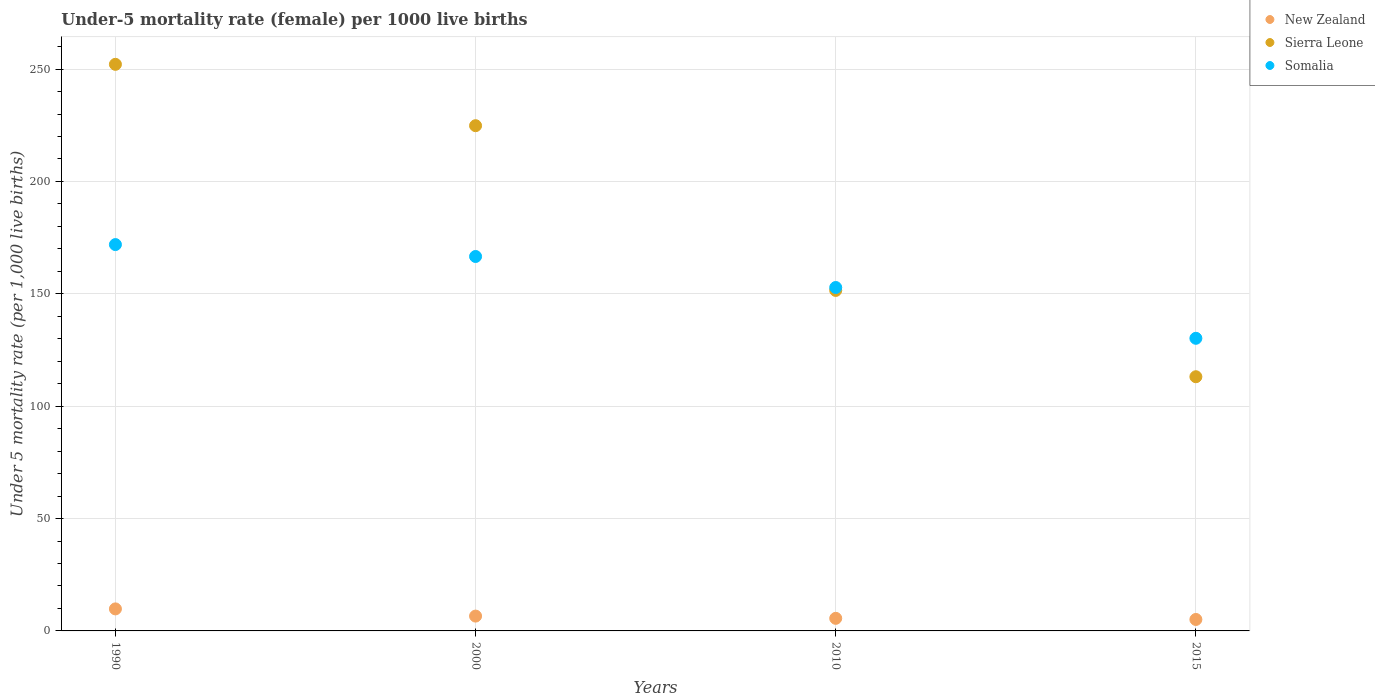How many different coloured dotlines are there?
Offer a very short reply. 3. What is the under-five mortality rate in Somalia in 2010?
Keep it short and to the point. 152.8. Across all years, what is the minimum under-five mortality rate in New Zealand?
Give a very brief answer. 5.1. In which year was the under-five mortality rate in Sierra Leone minimum?
Keep it short and to the point. 2015. What is the total under-five mortality rate in New Zealand in the graph?
Give a very brief answer. 27.1. What is the difference between the under-five mortality rate in New Zealand in 1990 and that in 2015?
Your response must be concise. 4.7. What is the difference between the under-five mortality rate in Somalia in 2015 and the under-five mortality rate in New Zealand in 2010?
Offer a very short reply. 124.6. What is the average under-five mortality rate in Sierra Leone per year?
Ensure brevity in your answer.  185.38. In the year 2015, what is the difference between the under-five mortality rate in Somalia and under-five mortality rate in Sierra Leone?
Offer a very short reply. 17.1. In how many years, is the under-five mortality rate in New Zealand greater than 250?
Your answer should be very brief. 0. What is the ratio of the under-five mortality rate in New Zealand in 1990 to that in 2000?
Keep it short and to the point. 1.48. Is the difference between the under-five mortality rate in Somalia in 1990 and 2000 greater than the difference between the under-five mortality rate in Sierra Leone in 1990 and 2000?
Your answer should be compact. No. What is the difference between the highest and the second highest under-five mortality rate in New Zealand?
Give a very brief answer. 3.2. What is the difference between the highest and the lowest under-five mortality rate in Sierra Leone?
Give a very brief answer. 139. In how many years, is the under-five mortality rate in Somalia greater than the average under-five mortality rate in Somalia taken over all years?
Make the answer very short. 2. Is it the case that in every year, the sum of the under-five mortality rate in Somalia and under-five mortality rate in Sierra Leone  is greater than the under-five mortality rate in New Zealand?
Make the answer very short. Yes. Is the under-five mortality rate in Somalia strictly greater than the under-five mortality rate in New Zealand over the years?
Offer a terse response. Yes. How many dotlines are there?
Your response must be concise. 3. Are the values on the major ticks of Y-axis written in scientific E-notation?
Your answer should be very brief. No. Does the graph contain any zero values?
Your response must be concise. No. How many legend labels are there?
Your answer should be compact. 3. What is the title of the graph?
Offer a terse response. Under-5 mortality rate (female) per 1000 live births. What is the label or title of the Y-axis?
Your response must be concise. Under 5 mortality rate (per 1,0 live births). What is the Under 5 mortality rate (per 1,000 live births) of New Zealand in 1990?
Give a very brief answer. 9.8. What is the Under 5 mortality rate (per 1,000 live births) in Sierra Leone in 1990?
Ensure brevity in your answer.  252.1. What is the Under 5 mortality rate (per 1,000 live births) of Somalia in 1990?
Offer a terse response. 171.9. What is the Under 5 mortality rate (per 1,000 live births) of New Zealand in 2000?
Make the answer very short. 6.6. What is the Under 5 mortality rate (per 1,000 live births) of Sierra Leone in 2000?
Your answer should be compact. 224.8. What is the Under 5 mortality rate (per 1,000 live births) of Somalia in 2000?
Ensure brevity in your answer.  166.6. What is the Under 5 mortality rate (per 1,000 live births) of Sierra Leone in 2010?
Ensure brevity in your answer.  151.5. What is the Under 5 mortality rate (per 1,000 live births) of Somalia in 2010?
Provide a short and direct response. 152.8. What is the Under 5 mortality rate (per 1,000 live births) of Sierra Leone in 2015?
Your answer should be very brief. 113.1. What is the Under 5 mortality rate (per 1,000 live births) of Somalia in 2015?
Keep it short and to the point. 130.2. Across all years, what is the maximum Under 5 mortality rate (per 1,000 live births) in New Zealand?
Offer a terse response. 9.8. Across all years, what is the maximum Under 5 mortality rate (per 1,000 live births) in Sierra Leone?
Give a very brief answer. 252.1. Across all years, what is the maximum Under 5 mortality rate (per 1,000 live births) in Somalia?
Provide a succinct answer. 171.9. Across all years, what is the minimum Under 5 mortality rate (per 1,000 live births) in Sierra Leone?
Your answer should be compact. 113.1. Across all years, what is the minimum Under 5 mortality rate (per 1,000 live births) of Somalia?
Provide a succinct answer. 130.2. What is the total Under 5 mortality rate (per 1,000 live births) in New Zealand in the graph?
Your answer should be compact. 27.1. What is the total Under 5 mortality rate (per 1,000 live births) in Sierra Leone in the graph?
Provide a short and direct response. 741.5. What is the total Under 5 mortality rate (per 1,000 live births) of Somalia in the graph?
Keep it short and to the point. 621.5. What is the difference between the Under 5 mortality rate (per 1,000 live births) in Sierra Leone in 1990 and that in 2000?
Offer a terse response. 27.3. What is the difference between the Under 5 mortality rate (per 1,000 live births) in New Zealand in 1990 and that in 2010?
Your answer should be compact. 4.2. What is the difference between the Under 5 mortality rate (per 1,000 live births) of Sierra Leone in 1990 and that in 2010?
Provide a succinct answer. 100.6. What is the difference between the Under 5 mortality rate (per 1,000 live births) in Sierra Leone in 1990 and that in 2015?
Your answer should be compact. 139. What is the difference between the Under 5 mortality rate (per 1,000 live births) of Somalia in 1990 and that in 2015?
Provide a short and direct response. 41.7. What is the difference between the Under 5 mortality rate (per 1,000 live births) of Sierra Leone in 2000 and that in 2010?
Make the answer very short. 73.3. What is the difference between the Under 5 mortality rate (per 1,000 live births) in Somalia in 2000 and that in 2010?
Offer a terse response. 13.8. What is the difference between the Under 5 mortality rate (per 1,000 live births) of New Zealand in 2000 and that in 2015?
Offer a very short reply. 1.5. What is the difference between the Under 5 mortality rate (per 1,000 live births) of Sierra Leone in 2000 and that in 2015?
Offer a very short reply. 111.7. What is the difference between the Under 5 mortality rate (per 1,000 live births) of Somalia in 2000 and that in 2015?
Offer a terse response. 36.4. What is the difference between the Under 5 mortality rate (per 1,000 live births) of Sierra Leone in 2010 and that in 2015?
Your answer should be compact. 38.4. What is the difference between the Under 5 mortality rate (per 1,000 live births) in Somalia in 2010 and that in 2015?
Your answer should be compact. 22.6. What is the difference between the Under 5 mortality rate (per 1,000 live births) in New Zealand in 1990 and the Under 5 mortality rate (per 1,000 live births) in Sierra Leone in 2000?
Keep it short and to the point. -215. What is the difference between the Under 5 mortality rate (per 1,000 live births) in New Zealand in 1990 and the Under 5 mortality rate (per 1,000 live births) in Somalia in 2000?
Offer a terse response. -156.8. What is the difference between the Under 5 mortality rate (per 1,000 live births) in Sierra Leone in 1990 and the Under 5 mortality rate (per 1,000 live births) in Somalia in 2000?
Your answer should be compact. 85.5. What is the difference between the Under 5 mortality rate (per 1,000 live births) of New Zealand in 1990 and the Under 5 mortality rate (per 1,000 live births) of Sierra Leone in 2010?
Your answer should be compact. -141.7. What is the difference between the Under 5 mortality rate (per 1,000 live births) in New Zealand in 1990 and the Under 5 mortality rate (per 1,000 live births) in Somalia in 2010?
Your answer should be very brief. -143. What is the difference between the Under 5 mortality rate (per 1,000 live births) of Sierra Leone in 1990 and the Under 5 mortality rate (per 1,000 live births) of Somalia in 2010?
Your answer should be compact. 99.3. What is the difference between the Under 5 mortality rate (per 1,000 live births) of New Zealand in 1990 and the Under 5 mortality rate (per 1,000 live births) of Sierra Leone in 2015?
Provide a succinct answer. -103.3. What is the difference between the Under 5 mortality rate (per 1,000 live births) of New Zealand in 1990 and the Under 5 mortality rate (per 1,000 live births) of Somalia in 2015?
Ensure brevity in your answer.  -120.4. What is the difference between the Under 5 mortality rate (per 1,000 live births) in Sierra Leone in 1990 and the Under 5 mortality rate (per 1,000 live births) in Somalia in 2015?
Provide a short and direct response. 121.9. What is the difference between the Under 5 mortality rate (per 1,000 live births) in New Zealand in 2000 and the Under 5 mortality rate (per 1,000 live births) in Sierra Leone in 2010?
Provide a short and direct response. -144.9. What is the difference between the Under 5 mortality rate (per 1,000 live births) of New Zealand in 2000 and the Under 5 mortality rate (per 1,000 live births) of Somalia in 2010?
Keep it short and to the point. -146.2. What is the difference between the Under 5 mortality rate (per 1,000 live births) in Sierra Leone in 2000 and the Under 5 mortality rate (per 1,000 live births) in Somalia in 2010?
Make the answer very short. 72. What is the difference between the Under 5 mortality rate (per 1,000 live births) of New Zealand in 2000 and the Under 5 mortality rate (per 1,000 live births) of Sierra Leone in 2015?
Make the answer very short. -106.5. What is the difference between the Under 5 mortality rate (per 1,000 live births) in New Zealand in 2000 and the Under 5 mortality rate (per 1,000 live births) in Somalia in 2015?
Offer a very short reply. -123.6. What is the difference between the Under 5 mortality rate (per 1,000 live births) in Sierra Leone in 2000 and the Under 5 mortality rate (per 1,000 live births) in Somalia in 2015?
Offer a terse response. 94.6. What is the difference between the Under 5 mortality rate (per 1,000 live births) in New Zealand in 2010 and the Under 5 mortality rate (per 1,000 live births) in Sierra Leone in 2015?
Make the answer very short. -107.5. What is the difference between the Under 5 mortality rate (per 1,000 live births) in New Zealand in 2010 and the Under 5 mortality rate (per 1,000 live births) in Somalia in 2015?
Give a very brief answer. -124.6. What is the difference between the Under 5 mortality rate (per 1,000 live births) in Sierra Leone in 2010 and the Under 5 mortality rate (per 1,000 live births) in Somalia in 2015?
Provide a succinct answer. 21.3. What is the average Under 5 mortality rate (per 1,000 live births) of New Zealand per year?
Keep it short and to the point. 6.78. What is the average Under 5 mortality rate (per 1,000 live births) in Sierra Leone per year?
Give a very brief answer. 185.38. What is the average Under 5 mortality rate (per 1,000 live births) in Somalia per year?
Your answer should be very brief. 155.38. In the year 1990, what is the difference between the Under 5 mortality rate (per 1,000 live births) in New Zealand and Under 5 mortality rate (per 1,000 live births) in Sierra Leone?
Give a very brief answer. -242.3. In the year 1990, what is the difference between the Under 5 mortality rate (per 1,000 live births) of New Zealand and Under 5 mortality rate (per 1,000 live births) of Somalia?
Offer a very short reply. -162.1. In the year 1990, what is the difference between the Under 5 mortality rate (per 1,000 live births) in Sierra Leone and Under 5 mortality rate (per 1,000 live births) in Somalia?
Your answer should be very brief. 80.2. In the year 2000, what is the difference between the Under 5 mortality rate (per 1,000 live births) of New Zealand and Under 5 mortality rate (per 1,000 live births) of Sierra Leone?
Offer a terse response. -218.2. In the year 2000, what is the difference between the Under 5 mortality rate (per 1,000 live births) of New Zealand and Under 5 mortality rate (per 1,000 live births) of Somalia?
Make the answer very short. -160. In the year 2000, what is the difference between the Under 5 mortality rate (per 1,000 live births) of Sierra Leone and Under 5 mortality rate (per 1,000 live births) of Somalia?
Make the answer very short. 58.2. In the year 2010, what is the difference between the Under 5 mortality rate (per 1,000 live births) of New Zealand and Under 5 mortality rate (per 1,000 live births) of Sierra Leone?
Provide a short and direct response. -145.9. In the year 2010, what is the difference between the Under 5 mortality rate (per 1,000 live births) in New Zealand and Under 5 mortality rate (per 1,000 live births) in Somalia?
Give a very brief answer. -147.2. In the year 2010, what is the difference between the Under 5 mortality rate (per 1,000 live births) of Sierra Leone and Under 5 mortality rate (per 1,000 live births) of Somalia?
Offer a very short reply. -1.3. In the year 2015, what is the difference between the Under 5 mortality rate (per 1,000 live births) in New Zealand and Under 5 mortality rate (per 1,000 live births) in Sierra Leone?
Your answer should be very brief. -108. In the year 2015, what is the difference between the Under 5 mortality rate (per 1,000 live births) in New Zealand and Under 5 mortality rate (per 1,000 live births) in Somalia?
Keep it short and to the point. -125.1. In the year 2015, what is the difference between the Under 5 mortality rate (per 1,000 live births) in Sierra Leone and Under 5 mortality rate (per 1,000 live births) in Somalia?
Make the answer very short. -17.1. What is the ratio of the Under 5 mortality rate (per 1,000 live births) in New Zealand in 1990 to that in 2000?
Provide a short and direct response. 1.48. What is the ratio of the Under 5 mortality rate (per 1,000 live births) in Sierra Leone in 1990 to that in 2000?
Give a very brief answer. 1.12. What is the ratio of the Under 5 mortality rate (per 1,000 live births) of Somalia in 1990 to that in 2000?
Your answer should be very brief. 1.03. What is the ratio of the Under 5 mortality rate (per 1,000 live births) in New Zealand in 1990 to that in 2010?
Offer a terse response. 1.75. What is the ratio of the Under 5 mortality rate (per 1,000 live births) in Sierra Leone in 1990 to that in 2010?
Make the answer very short. 1.66. What is the ratio of the Under 5 mortality rate (per 1,000 live births) in New Zealand in 1990 to that in 2015?
Your answer should be compact. 1.92. What is the ratio of the Under 5 mortality rate (per 1,000 live births) of Sierra Leone in 1990 to that in 2015?
Provide a short and direct response. 2.23. What is the ratio of the Under 5 mortality rate (per 1,000 live births) of Somalia in 1990 to that in 2015?
Provide a short and direct response. 1.32. What is the ratio of the Under 5 mortality rate (per 1,000 live births) in New Zealand in 2000 to that in 2010?
Your answer should be compact. 1.18. What is the ratio of the Under 5 mortality rate (per 1,000 live births) in Sierra Leone in 2000 to that in 2010?
Your answer should be compact. 1.48. What is the ratio of the Under 5 mortality rate (per 1,000 live births) of Somalia in 2000 to that in 2010?
Your answer should be compact. 1.09. What is the ratio of the Under 5 mortality rate (per 1,000 live births) of New Zealand in 2000 to that in 2015?
Provide a short and direct response. 1.29. What is the ratio of the Under 5 mortality rate (per 1,000 live births) in Sierra Leone in 2000 to that in 2015?
Offer a very short reply. 1.99. What is the ratio of the Under 5 mortality rate (per 1,000 live births) of Somalia in 2000 to that in 2015?
Offer a terse response. 1.28. What is the ratio of the Under 5 mortality rate (per 1,000 live births) of New Zealand in 2010 to that in 2015?
Keep it short and to the point. 1.1. What is the ratio of the Under 5 mortality rate (per 1,000 live births) of Sierra Leone in 2010 to that in 2015?
Make the answer very short. 1.34. What is the ratio of the Under 5 mortality rate (per 1,000 live births) in Somalia in 2010 to that in 2015?
Make the answer very short. 1.17. What is the difference between the highest and the second highest Under 5 mortality rate (per 1,000 live births) of Sierra Leone?
Offer a terse response. 27.3. What is the difference between the highest and the lowest Under 5 mortality rate (per 1,000 live births) of New Zealand?
Give a very brief answer. 4.7. What is the difference between the highest and the lowest Under 5 mortality rate (per 1,000 live births) of Sierra Leone?
Your answer should be compact. 139. What is the difference between the highest and the lowest Under 5 mortality rate (per 1,000 live births) in Somalia?
Provide a succinct answer. 41.7. 